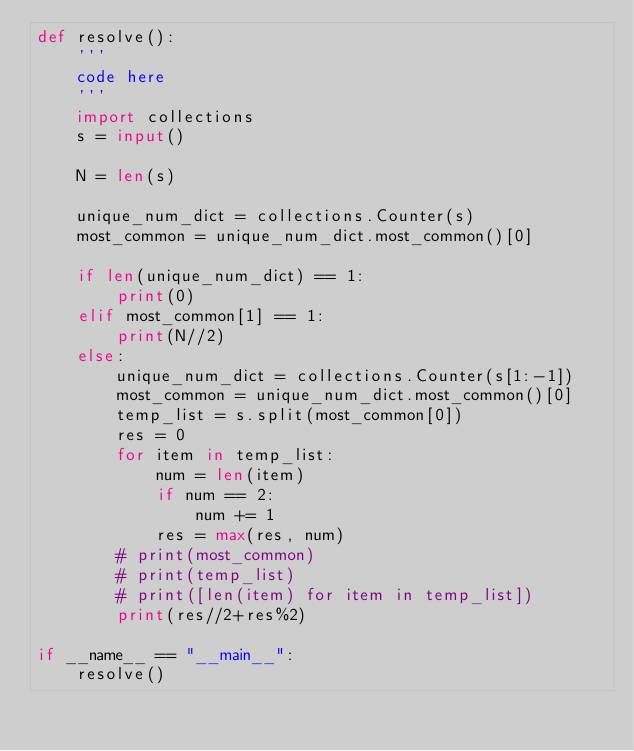<code> <loc_0><loc_0><loc_500><loc_500><_Python_>def resolve():
    '''
    code here
    '''
    import collections
    s = input()

    N = len(s)

    unique_num_dict = collections.Counter(s)
    most_common = unique_num_dict.most_common()[0]

    if len(unique_num_dict) == 1:
        print(0)
    elif most_common[1] == 1:
        print(N//2)
    else:
        unique_num_dict = collections.Counter(s[1:-1])
        most_common = unique_num_dict.most_common()[0]
        temp_list = s.split(most_common[0])
        res = 0
        for item in temp_list:
            num = len(item)
            if num == 2:
                num += 1
            res = max(res, num)
        # print(most_common)
        # print(temp_list)
        # print([len(item) for item in temp_list])
        print(res//2+res%2)

if __name__ == "__main__":
    resolve()
</code> 